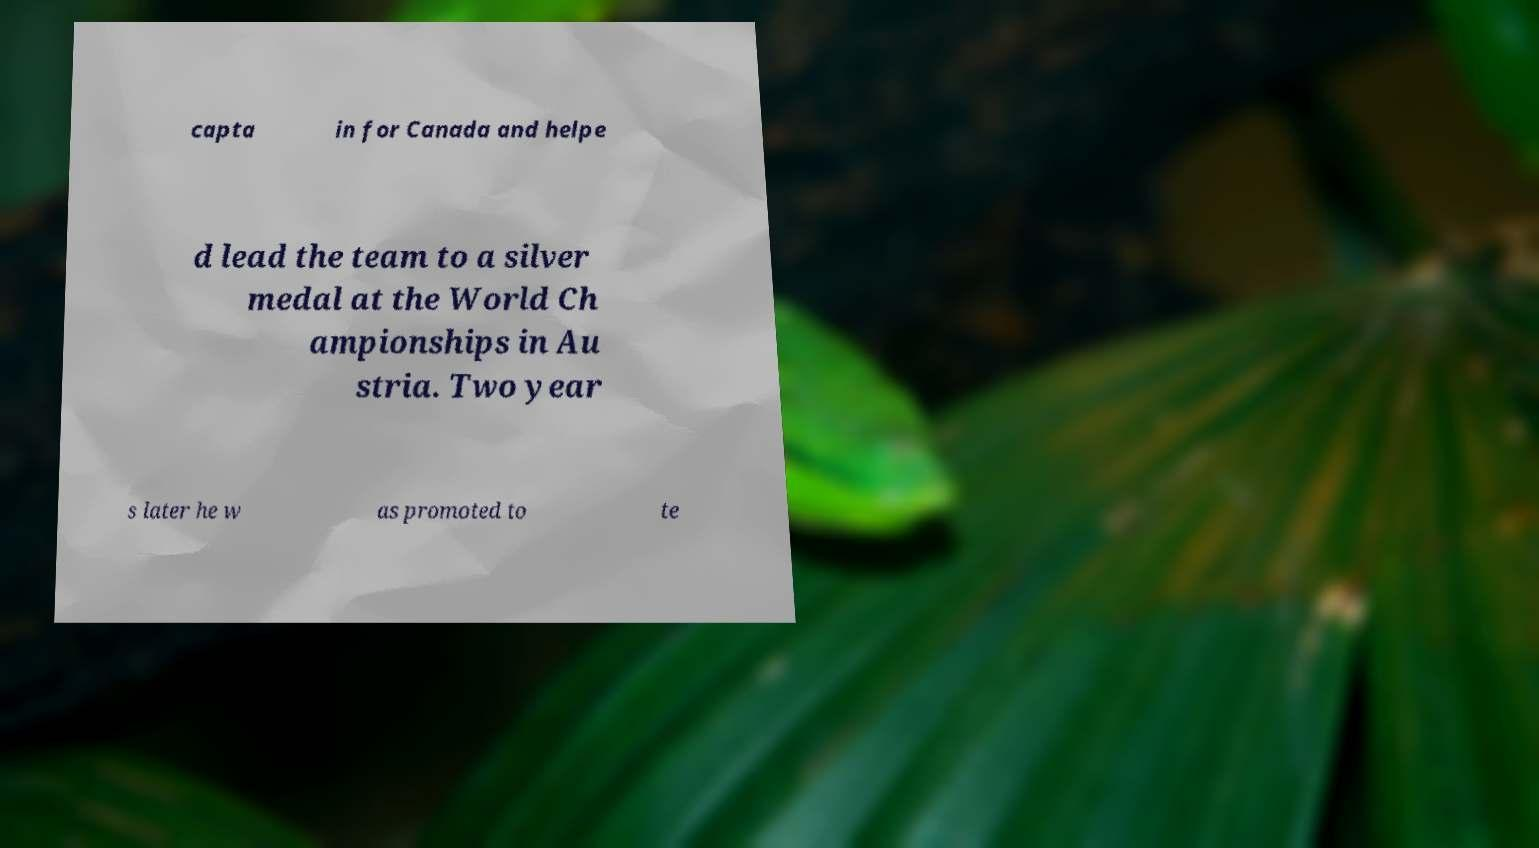Could you assist in decoding the text presented in this image and type it out clearly? capta in for Canada and helpe d lead the team to a silver medal at the World Ch ampionships in Au stria. Two year s later he w as promoted to te 